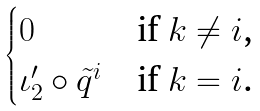<formula> <loc_0><loc_0><loc_500><loc_500>\begin{cases} 0 & \text {if $k \ne i$,} \\ \iota ^ { \prime } _ { 2 } \circ \tilde { q } ^ { i } & \text {if $k = i$.} \end{cases}</formula> 